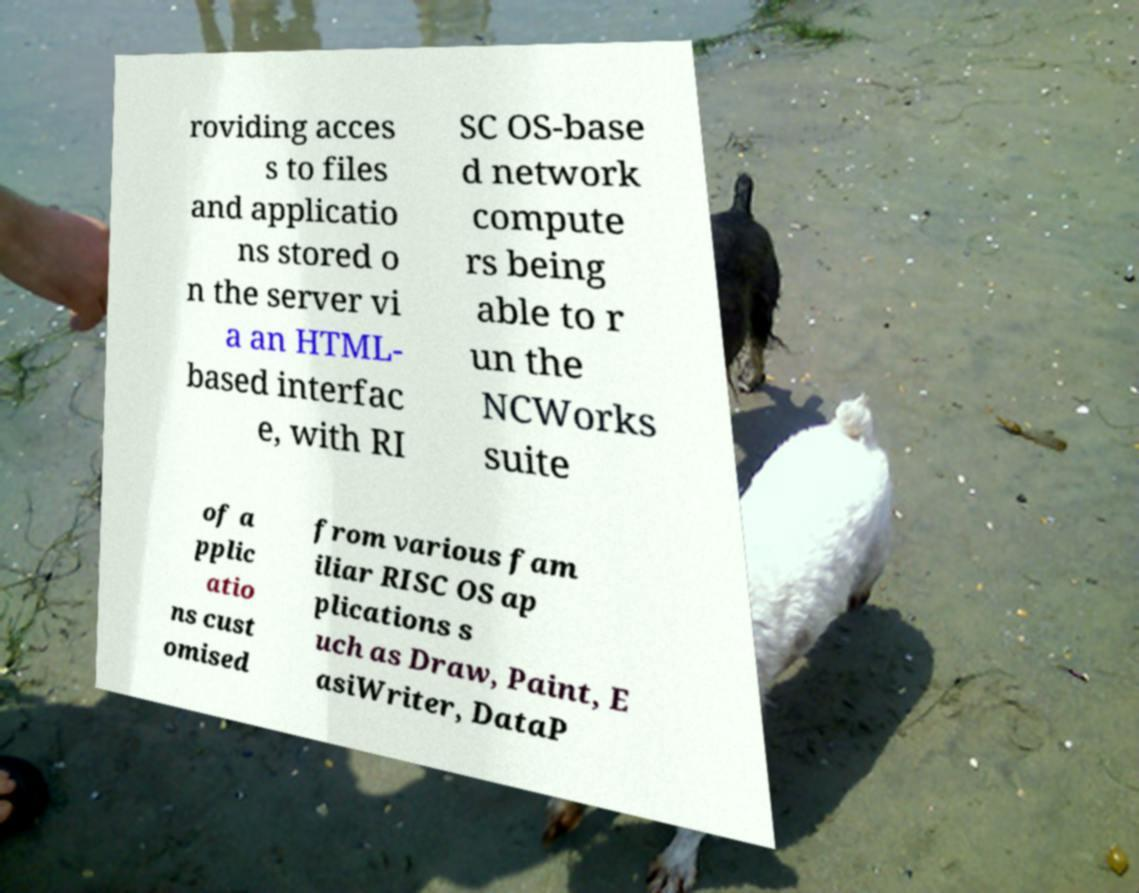Could you extract and type out the text from this image? roviding acces s to files and applicatio ns stored o n the server vi a an HTML- based interfac e, with RI SC OS-base d network compute rs being able to r un the NCWorks suite of a pplic atio ns cust omised from various fam iliar RISC OS ap plications s uch as Draw, Paint, E asiWriter, DataP 